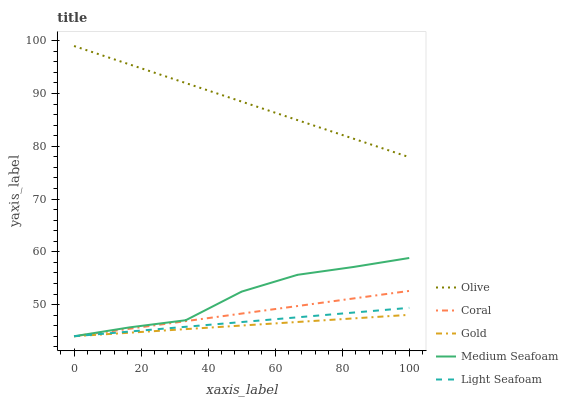Does Gold have the minimum area under the curve?
Answer yes or no. Yes. Does Olive have the maximum area under the curve?
Answer yes or no. Yes. Does Coral have the minimum area under the curve?
Answer yes or no. No. Does Coral have the maximum area under the curve?
Answer yes or no. No. Is Light Seafoam the smoothest?
Answer yes or no. Yes. Is Medium Seafoam the roughest?
Answer yes or no. Yes. Is Coral the smoothest?
Answer yes or no. No. Is Coral the roughest?
Answer yes or no. No. Does Coral have the lowest value?
Answer yes or no. Yes. Does Olive have the highest value?
Answer yes or no. Yes. Does Coral have the highest value?
Answer yes or no. No. Is Gold less than Olive?
Answer yes or no. Yes. Is Olive greater than Gold?
Answer yes or no. Yes. Does Light Seafoam intersect Coral?
Answer yes or no. Yes. Is Light Seafoam less than Coral?
Answer yes or no. No. Is Light Seafoam greater than Coral?
Answer yes or no. No. Does Gold intersect Olive?
Answer yes or no. No. 